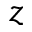Convert formula to latex. <formula><loc_0><loc_0><loc_500><loc_500>z</formula> 